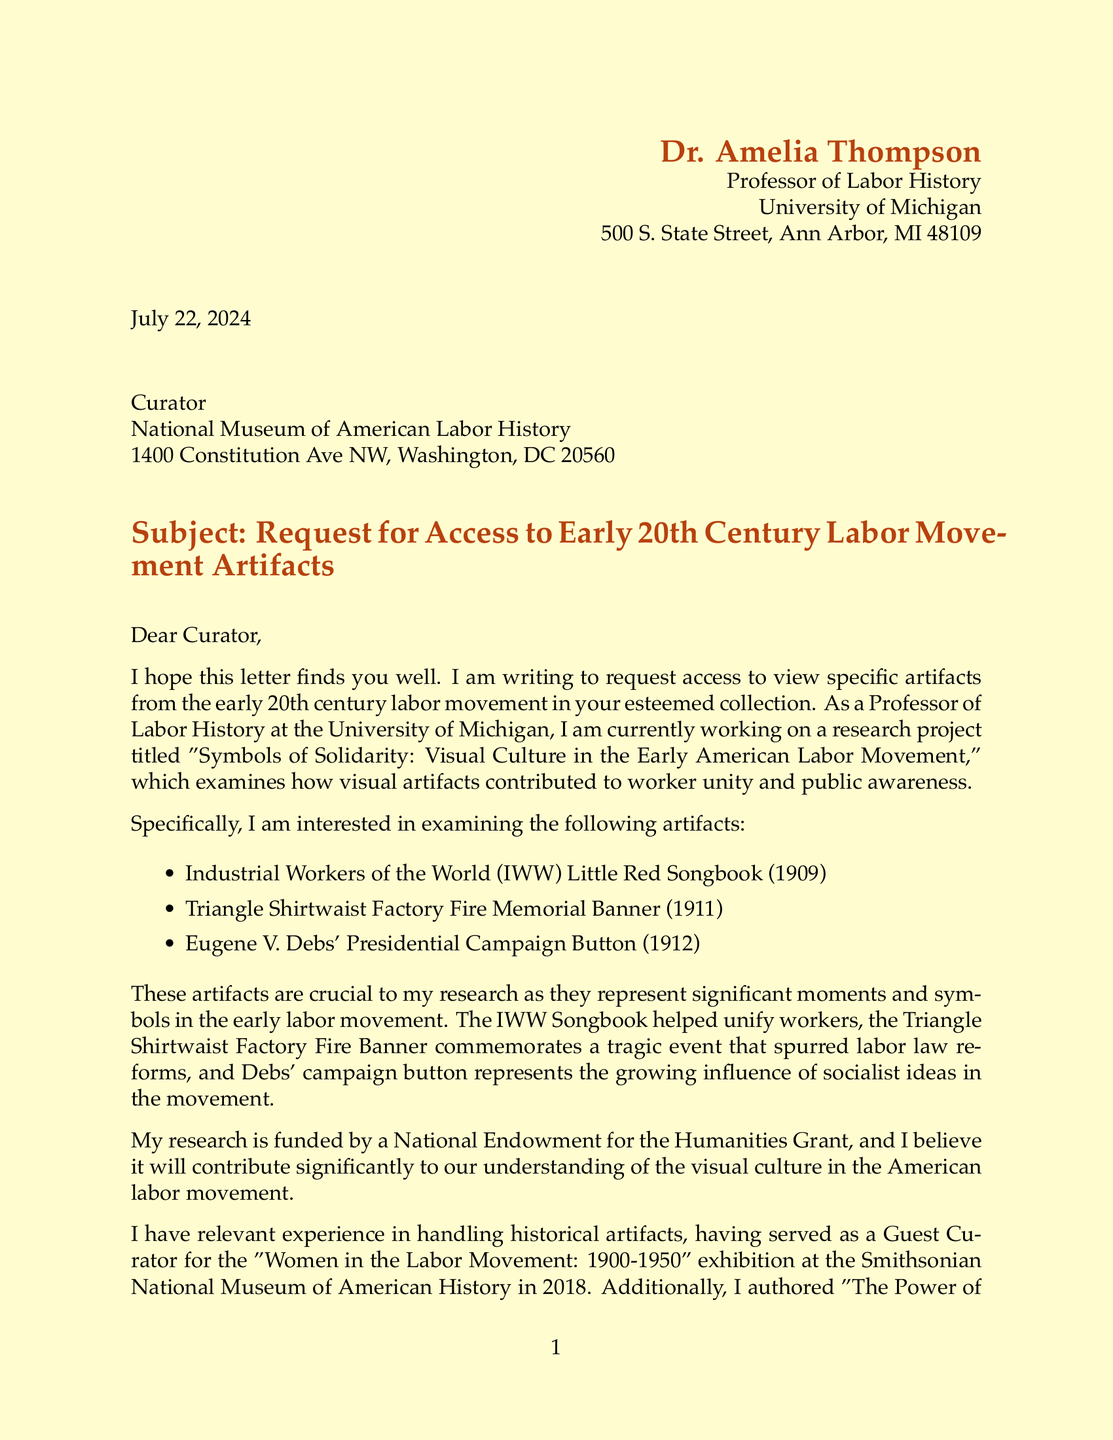What is the sender's name? The sender of the letter is Dr. Amelia Thompson, as stated in the letter's header.
Answer: Dr. Amelia Thompson What is the recipient's title? The recipient's title is mentioned in the address section as "Curator."
Answer: Curator What year was the IWW Little Red Songbook published? The published year of the artifact is indicated in the list of requested artifacts.
Answer: 1909 What is the research project title? The title of the research project is provided in the introductory section of the letter.
Answer: Symbols of Solidarity: Visual Culture in the Early American Labor Movement How many artifacts are requested? The letter lists three specific artifacts that Dr. Amelia Thompson is requesting access to.
Answer: Three What is the funding source for the research? The letter mentions the National Endowment for the Humanities Grant as the funding source for the research.
Answer: National Endowment for the Humanities Grant In what year did Dr. Amelia Thompson serve as a Guest Curator? The year mentions her role as Guest Curator for a specific exhibition in the document.
Answer: 2018 What special requirement does Dr. Thompson mention for her visit? The letter notes a specific requirement related to equipment for documentation purposes.
Answer: Access to high-resolution photography equipment What recent discovery does Dr. Thompson mention? The letter states the discovery of correspondence between two well-known figures in labor history.
Answer: Newly uncovered correspondence between Samuel Gompers and Mary Harris 'Mother' Jones 